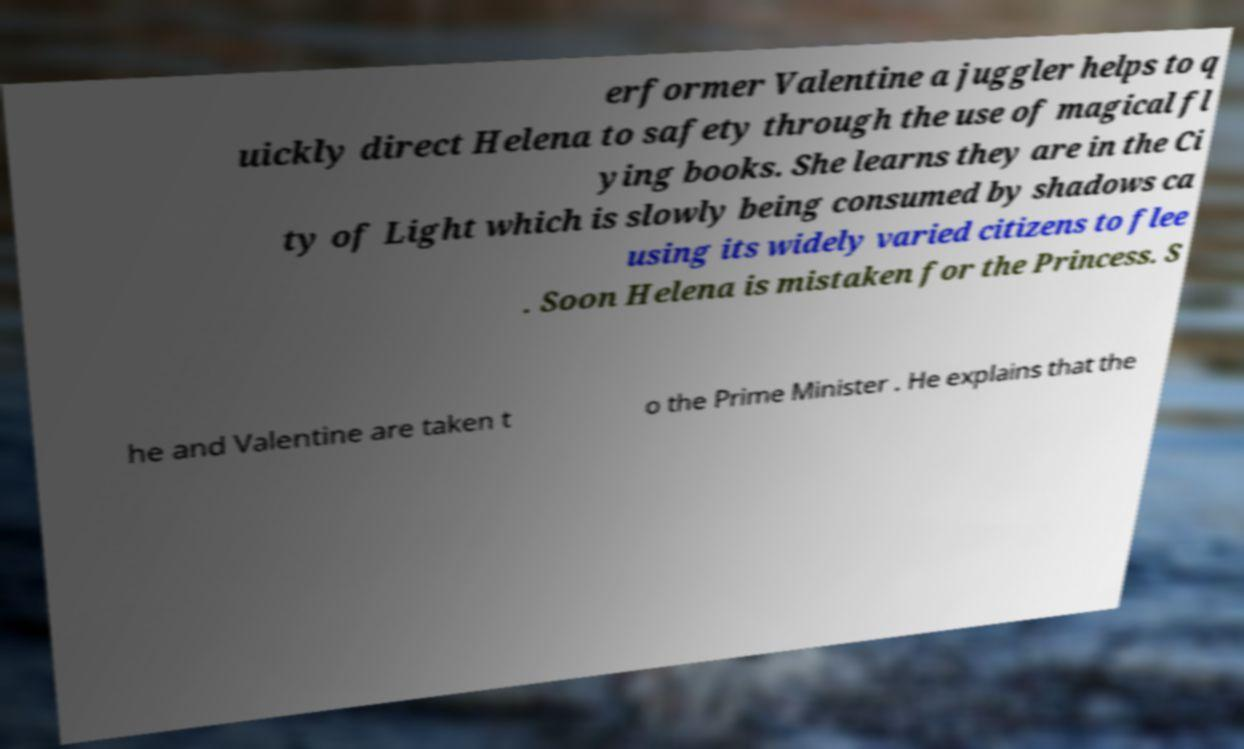For documentation purposes, I need the text within this image transcribed. Could you provide that? erformer Valentine a juggler helps to q uickly direct Helena to safety through the use of magical fl ying books. She learns they are in the Ci ty of Light which is slowly being consumed by shadows ca using its widely varied citizens to flee . Soon Helena is mistaken for the Princess. S he and Valentine are taken t o the Prime Minister . He explains that the 